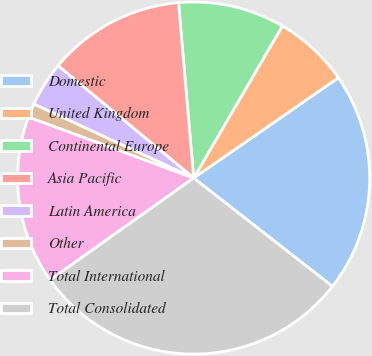<chart> <loc_0><loc_0><loc_500><loc_500><pie_chart><fcel>Domestic<fcel>United Kingdom<fcel>Continental Europe<fcel>Asia Pacific<fcel>Latin America<fcel>Other<fcel>Total International<fcel>Total Consolidated<nl><fcel>20.2%<fcel>6.95%<fcel>9.78%<fcel>12.62%<fcel>4.11%<fcel>1.28%<fcel>15.45%<fcel>29.62%<nl></chart> 